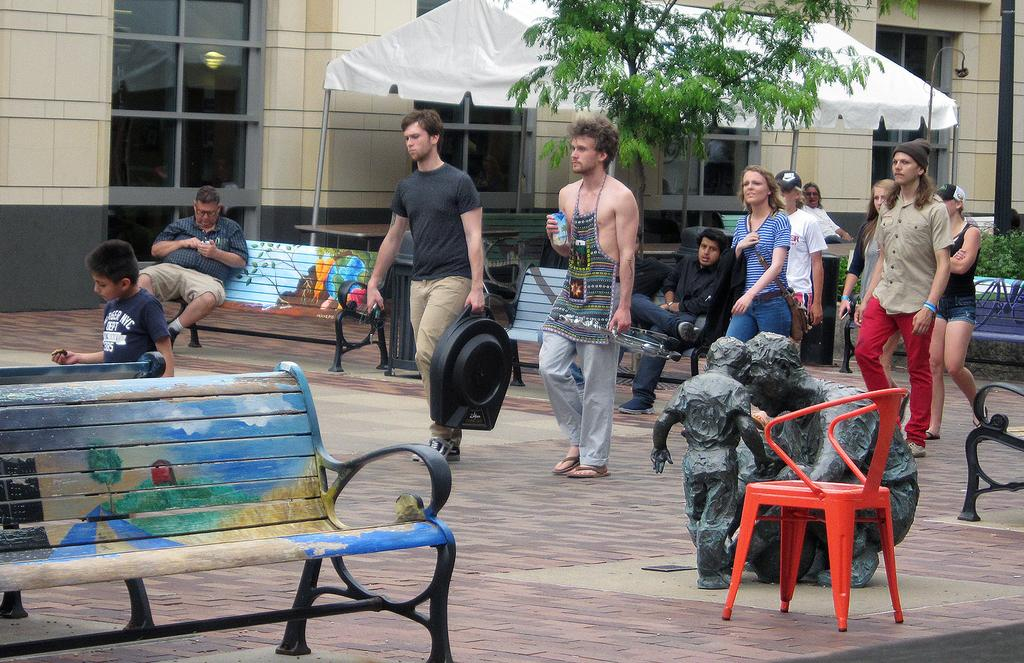How many people are in the image? There is a group of people in the image. What are some of the people doing in the image? Some people are sitting on a bench, while others are walking on the ground. What structures can be seen in the image? There is a building in the image. What type of vegetation is present in the image? There is a tree in the image. How many ducks are sitting on the bench in the image? There are no ducks present in the image; it features a group of people. What type of class is being taught in the image? There is no class or teaching activity depicted in the image. 